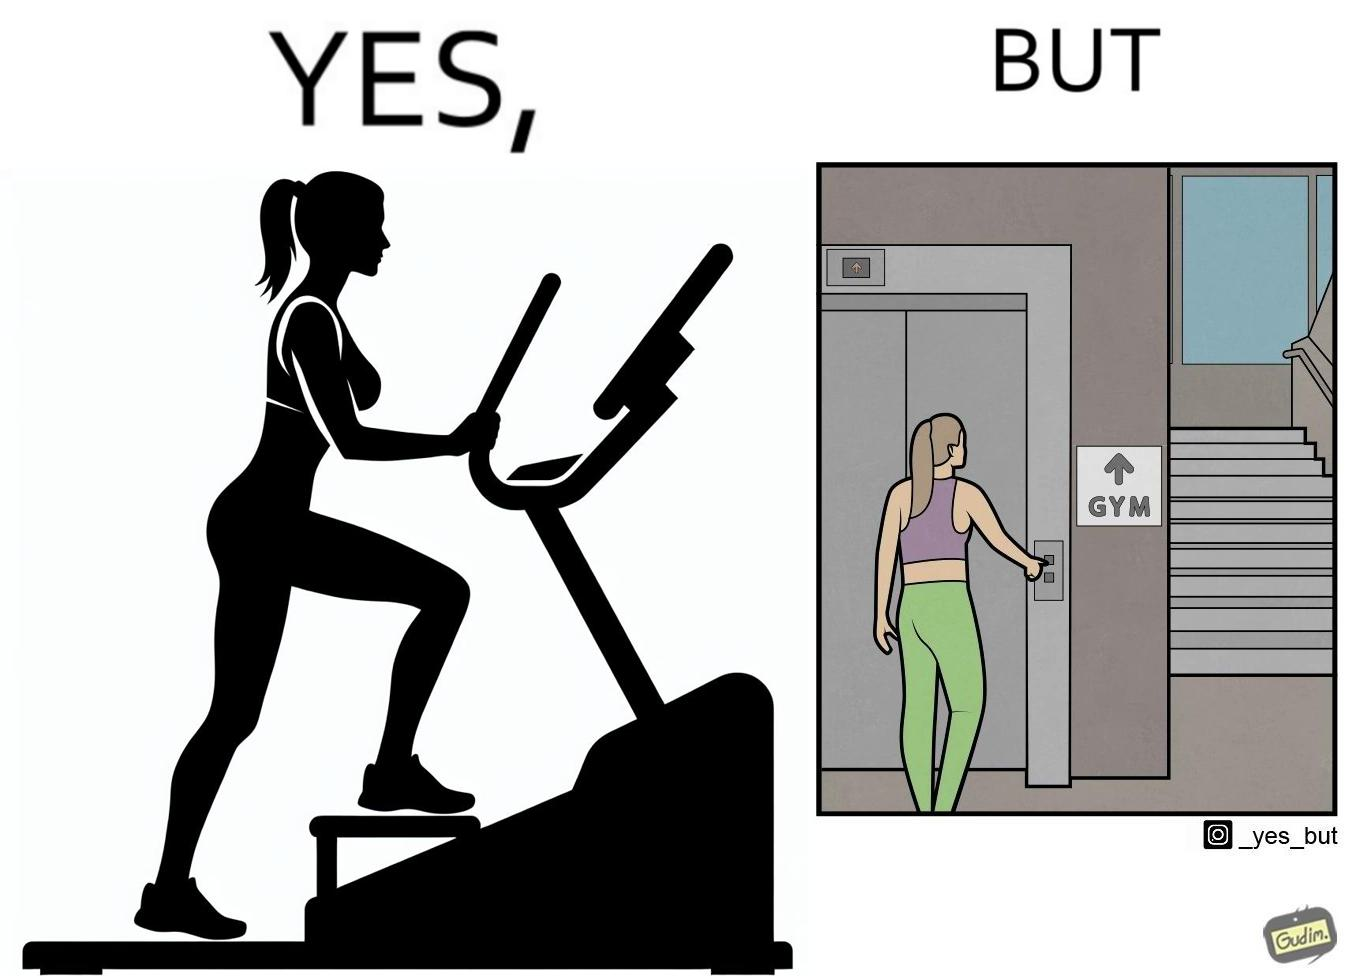Describe what you see in the left and right parts of this image. In the left part of the image: a woman is seen using the stair climber machine at some gym In the right part of the image: a woman calling for the lift to avoid climbing up the stairs for going to the gym 